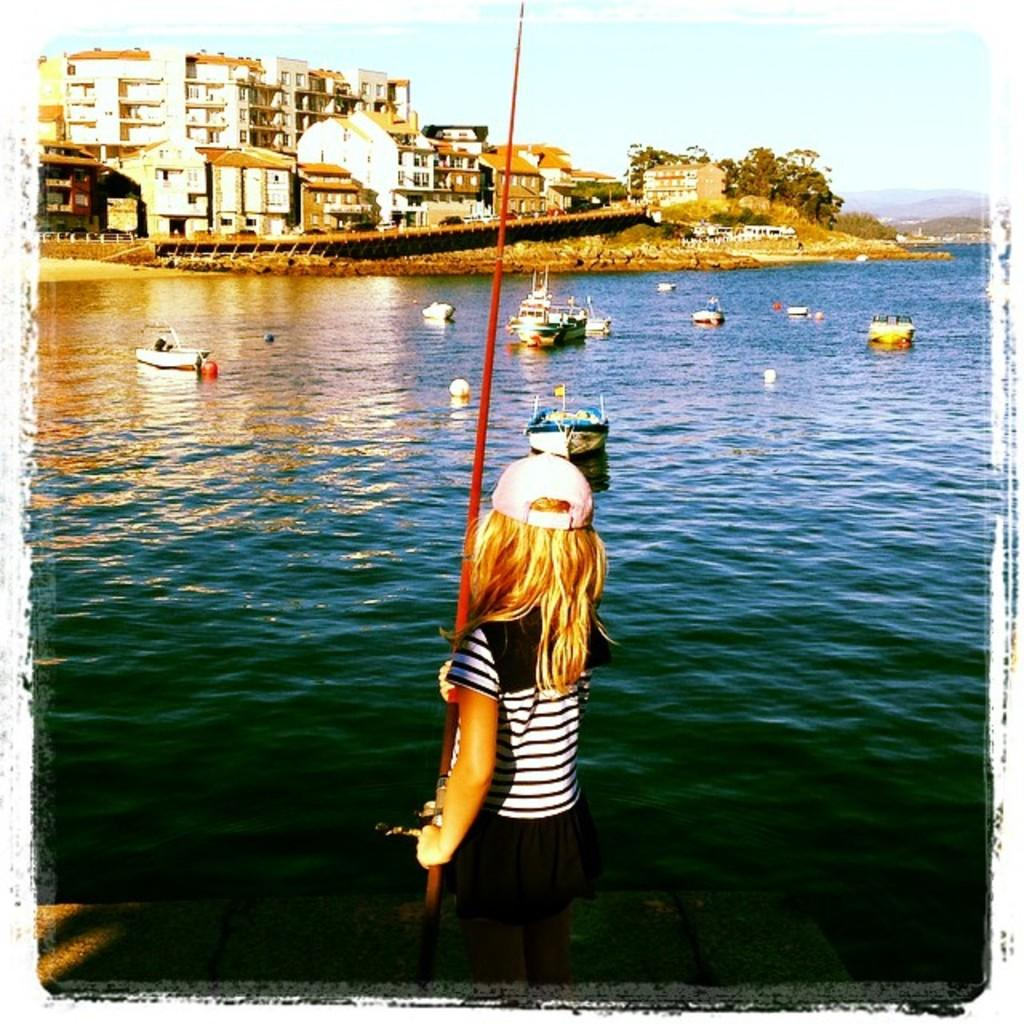What is the girl in the image holding? The girl is holding a rod in the image. What can be seen in the water in front of the girl? There are ships in the water in front of the girl. What is visible in the background of the image? There are buildings, trees, and the sky visible in the background of the image. What type of bee can be seen flying around the girl in the image? There is no bee present in the image; the girl is holding a rod and there are ships in the water in front of her. What type of cabbage is growing in the background of the image? There is no cabbage present in the image; the background features buildings, trees, and the sky. 